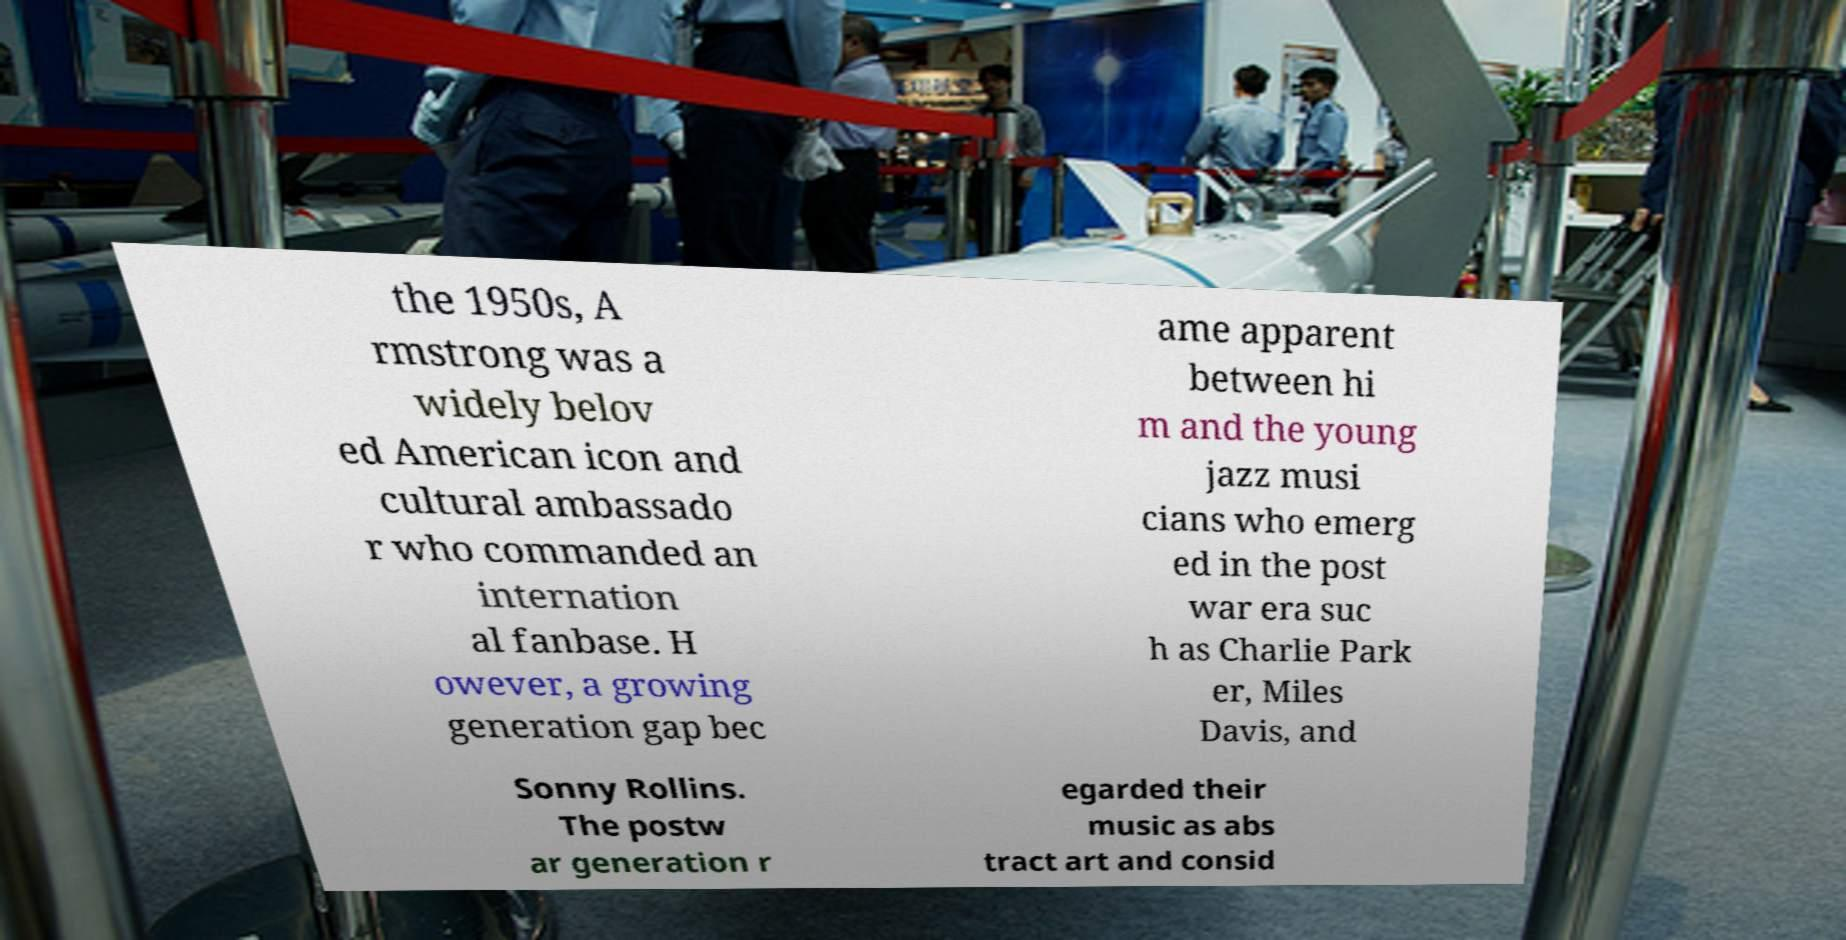What messages or text are displayed in this image? I need them in a readable, typed format. the 1950s, A rmstrong was a widely belov ed American icon and cultural ambassado r who commanded an internation al fanbase. H owever, a growing generation gap bec ame apparent between hi m and the young jazz musi cians who emerg ed in the post war era suc h as Charlie Park er, Miles Davis, and Sonny Rollins. The postw ar generation r egarded their music as abs tract art and consid 